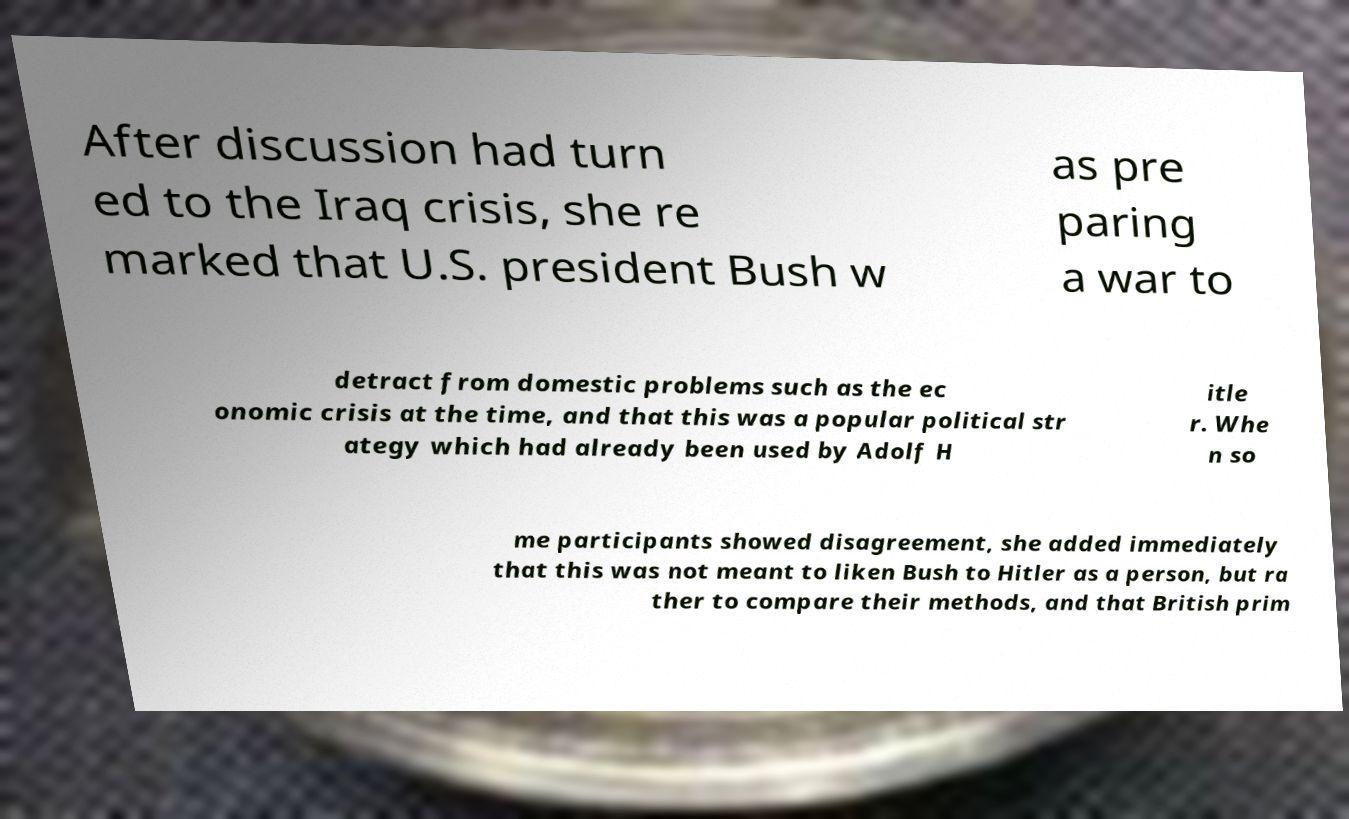Can you accurately transcribe the text from the provided image for me? After discussion had turn ed to the Iraq crisis, she re marked that U.S. president Bush w as pre paring a war to detract from domestic problems such as the ec onomic crisis at the time, and that this was a popular political str ategy which had already been used by Adolf H itle r. Whe n so me participants showed disagreement, she added immediately that this was not meant to liken Bush to Hitler as a person, but ra ther to compare their methods, and that British prim 